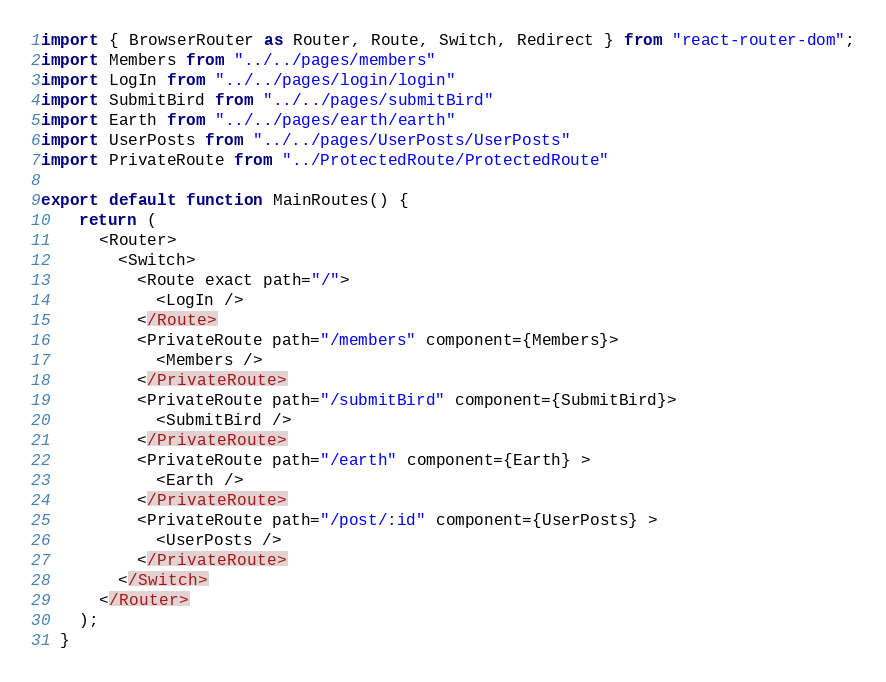Convert code to text. <code><loc_0><loc_0><loc_500><loc_500><_JavaScript_>import { BrowserRouter as Router, Route, Switch, Redirect } from "react-router-dom";
import Members from "../../pages/members"
import LogIn from "../../pages/login/login"
import SubmitBird from "../../pages/submitBird"
import Earth from "../../pages/earth/earth"
import UserPosts from "../../pages/UserPosts/UserPosts"
import PrivateRoute from "../ProtectedRoute/ProtectedRoute"

export default function MainRoutes() {
    return (
      <Router>
        <Switch>
          <Route exact path="/">
            <LogIn />
          </Route>
          <PrivateRoute path="/members" component={Members}>
            <Members />
          </PrivateRoute>
          <PrivateRoute path="/submitBird" component={SubmitBird}>
            <SubmitBird />
          </PrivateRoute>
          <PrivateRoute path="/earth" component={Earth} >
            <Earth />
          </PrivateRoute>
          <PrivateRoute path="/post/:id" component={UserPosts} >
            <UserPosts />
          </PrivateRoute>
        </Switch>
      </Router>
    );
  }</code> 